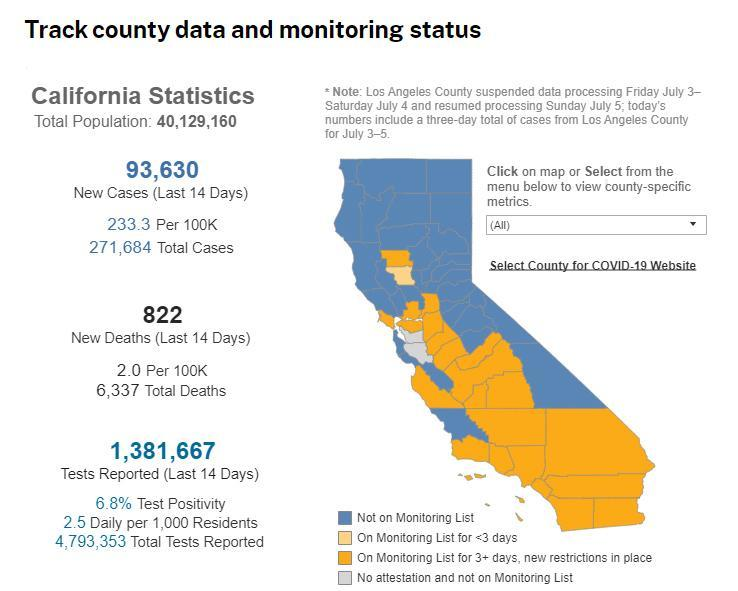What is the number of deaths in the last 14 days?
Answer the question with a short phrase. 822 What is the difference between total population and tests reported in the last 14 days? 38,747,493 What is the difference between total tests reported and tests reported in the last 14 days? 3,411,686 What is the number of new cases? 93,630 